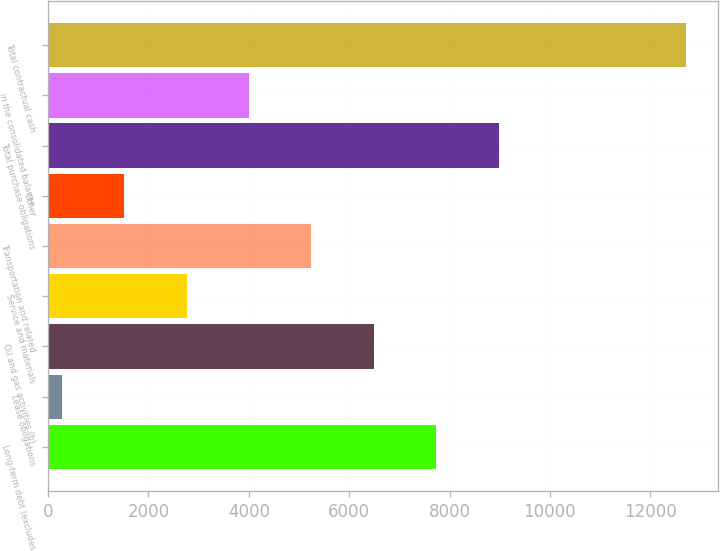Convert chart to OTSL. <chart><loc_0><loc_0><loc_500><loc_500><bar_chart><fcel>Long-term debt (excludes<fcel>Lease obligations<fcel>Oil and gas activities (b)<fcel>Service and materials<fcel>Transportation and related<fcel>Other<fcel>Total purchase obligations<fcel>in the consolidated balance<fcel>Total contractual cash<nl><fcel>7736.6<fcel>275<fcel>6493<fcel>2762.2<fcel>5249.4<fcel>1518.6<fcel>8980.2<fcel>4005.8<fcel>12711<nl></chart> 